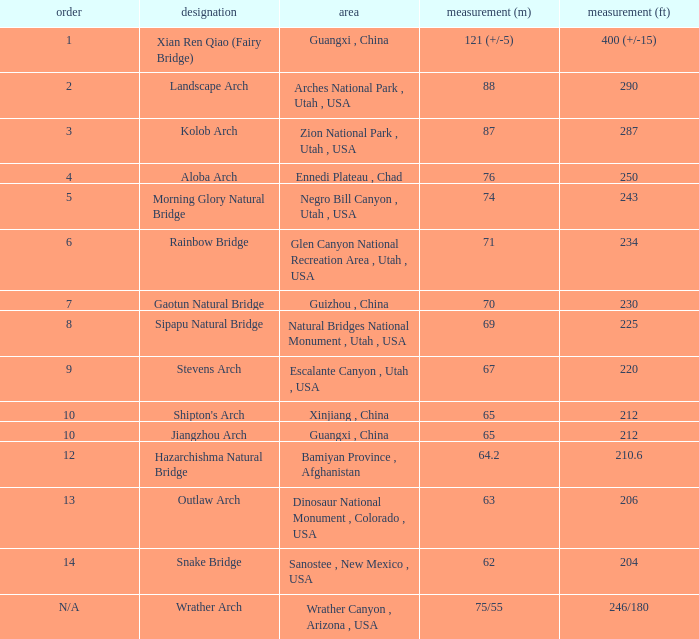Where is the longest arch with a length in meters of 63? Dinosaur National Monument , Colorado , USA. 